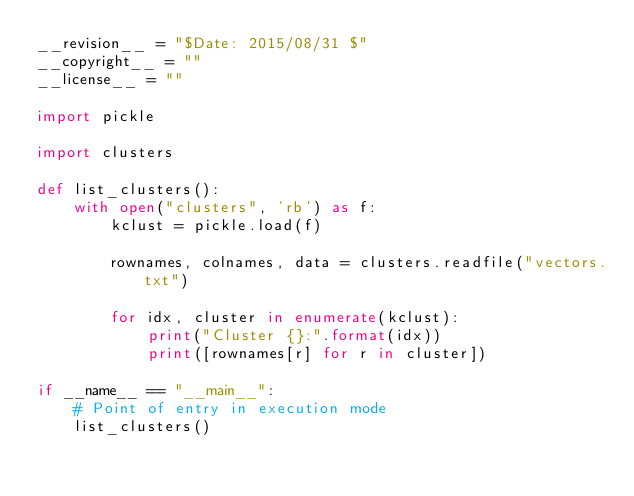<code> <loc_0><loc_0><loc_500><loc_500><_Python_>__revision__ = "$Date: 2015/08/31 $"
__copyright__ = ""
__license__ = ""

import pickle

import clusters

def list_clusters():
    with open("clusters", 'rb') as f:
        kclust = pickle.load(f)

        rownames, colnames, data = clusters.readfile("vectors.txt")

        for idx, cluster in enumerate(kclust):
            print("Cluster {}:".format(idx))
            print([rownames[r] for r in cluster])

if __name__ == "__main__":
    # Point of entry in execution mode
    list_clusters()
</code> 